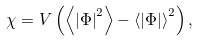<formula> <loc_0><loc_0><loc_500><loc_500>\chi = V \left ( \left < \left | \Phi \right | ^ { 2 } \right > - \left < \left | \Phi \right | \right > ^ { 2 } \right ) ,</formula> 